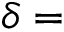Convert formula to latex. <formula><loc_0><loc_0><loc_500><loc_500>\delta =</formula> 